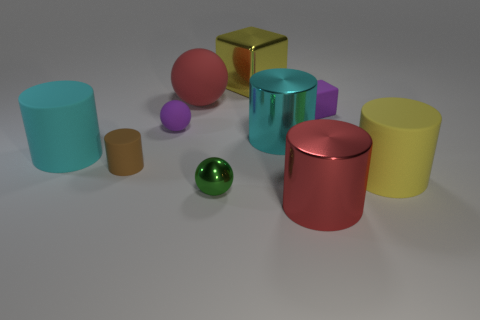Subtract all rubber balls. How many balls are left? 1 Subtract all yellow cubes. How many cyan cylinders are left? 2 Subtract all cyan cylinders. How many cylinders are left? 3 Subtract 1 spheres. How many spheres are left? 2 Subtract all spheres. How many objects are left? 7 Subtract all green cylinders. Subtract all brown spheres. How many cylinders are left? 5 Add 1 small brown cylinders. How many small brown cylinders are left? 2 Add 2 green rubber objects. How many green rubber objects exist? 2 Subtract 0 red cubes. How many objects are left? 10 Subtract all big cyan rubber things. Subtract all tiny matte balls. How many objects are left? 8 